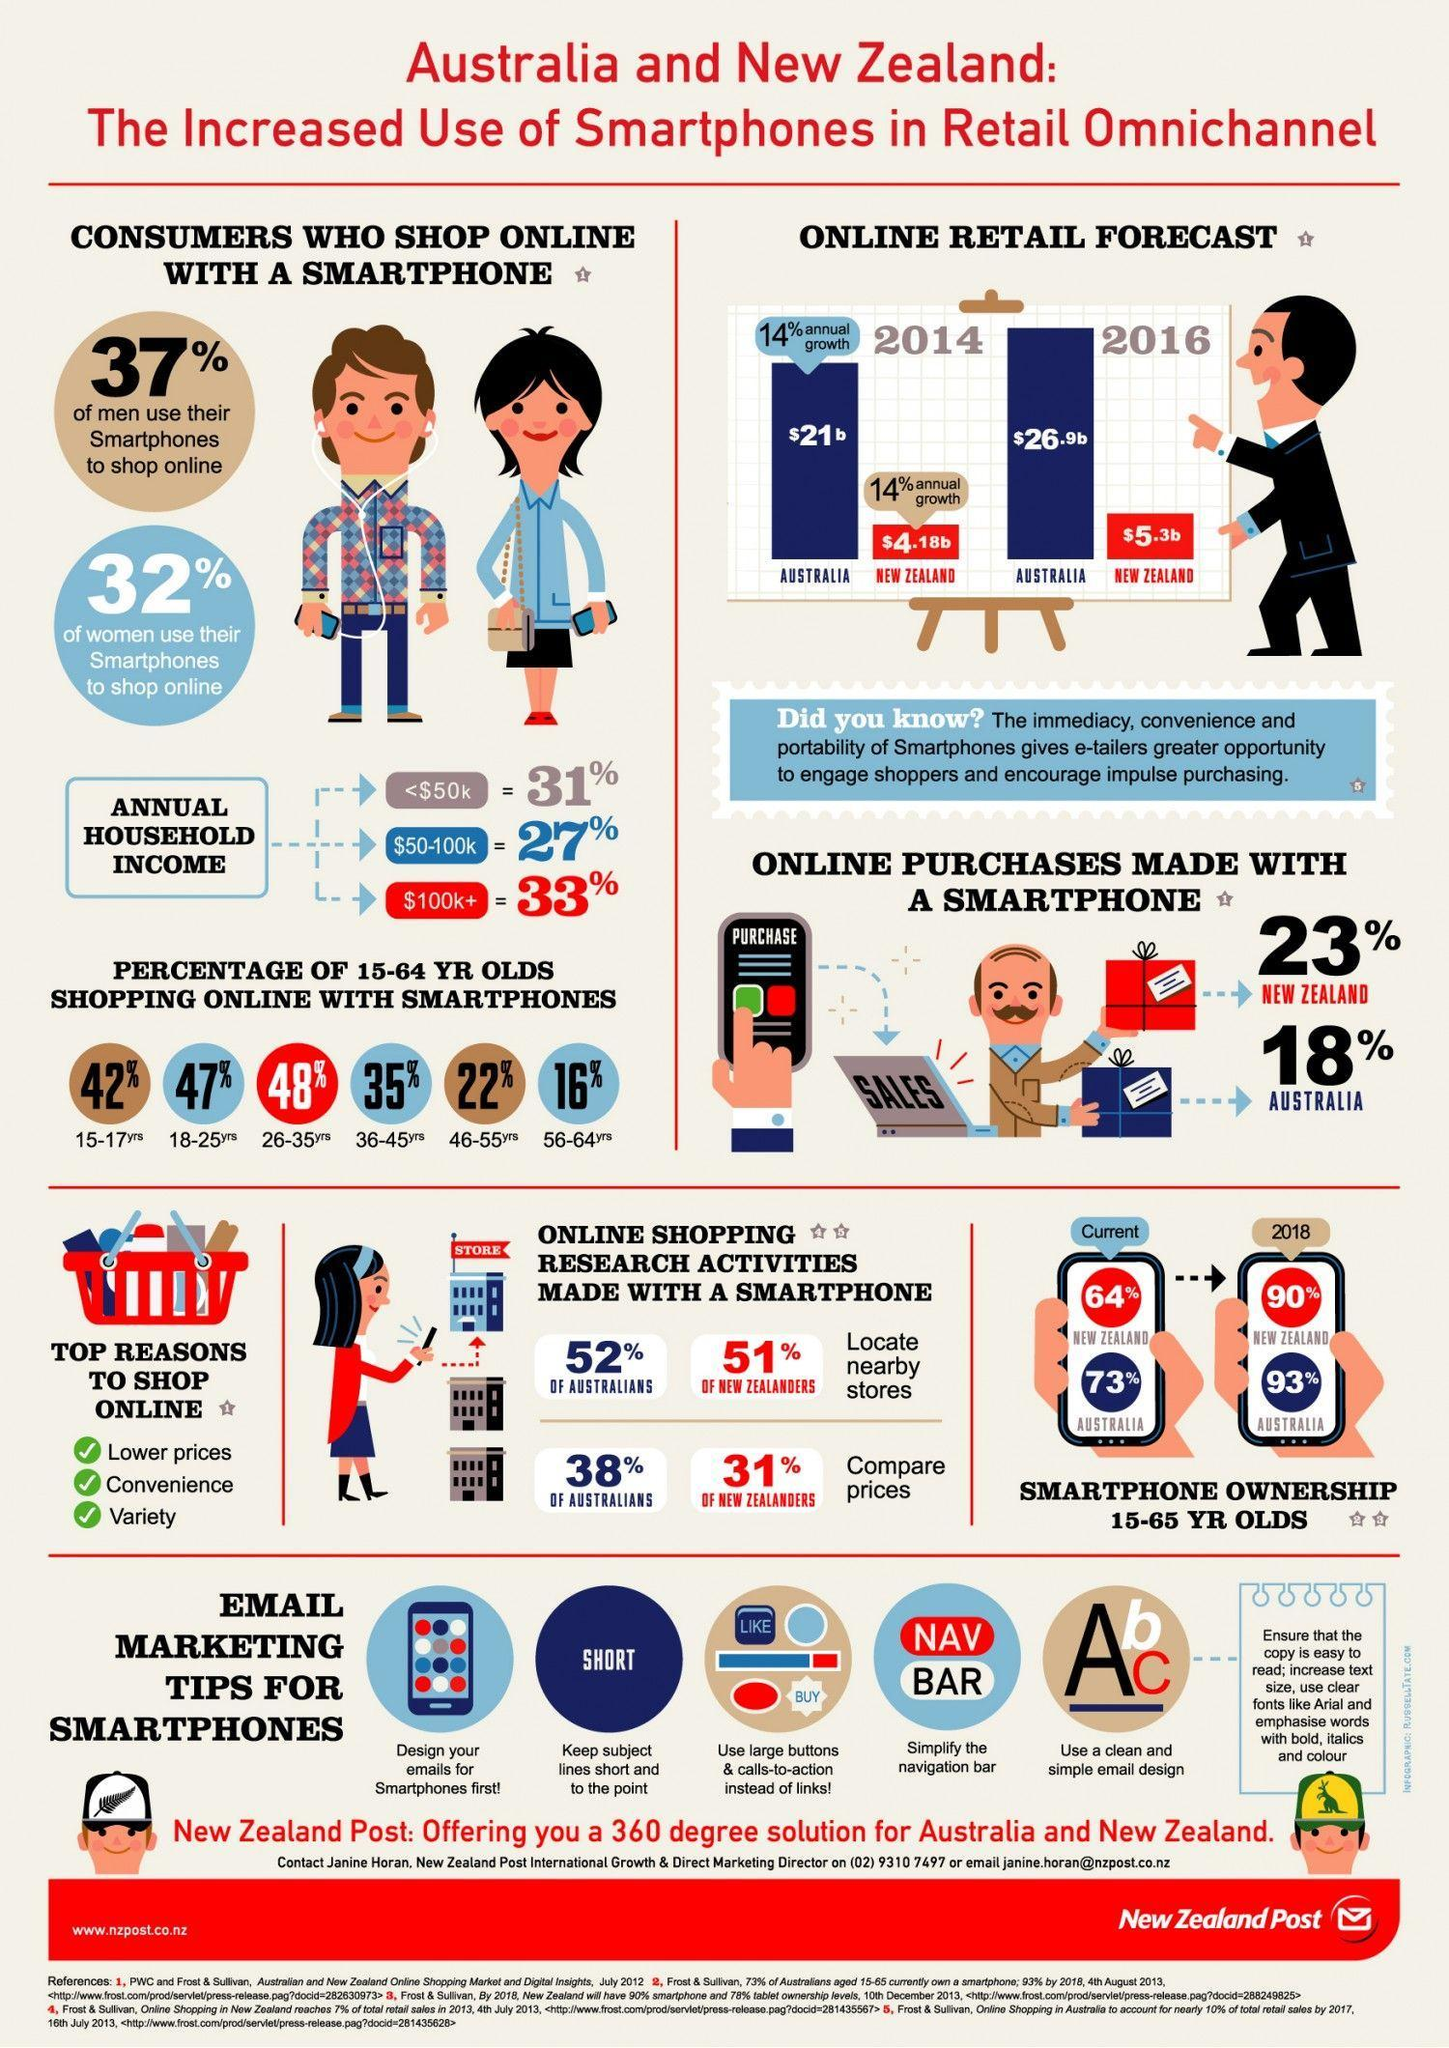What is the online retail sales of smartphones in Australia in the year 2016?
Answer the question with a short phrase. $5.3b What percentage of consumers have Annual household income of  $50-100k in Austraila & New Zealand? 27% What percentage of Australians have searched in the smartphones to locate nearby stores? 52% What percentage of annual growth is observed for the online retail sales of  smart phones in Australia in 2014? 14% What percentage of women do not use their smartphones to shop online in Austraila & New Zealand? 68% What is the online retail sales of smartphones in Australia in the year 2014? $21b Which age group people in Austraila & New Zealand are more in to online shopping with smartphones? 26-35yrs What percentage of men use their smartphones to shop online in Austraila & New Zealand? 37% Which age group people in Austraila & New Zealand are least interested in online shopping with smartphones? 56-64yrs What percentage of consumers have Annual household income of $100k+ in Austraila & New Zealand? 33% 